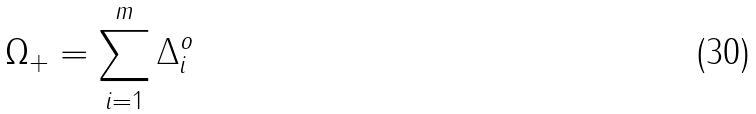<formula> <loc_0><loc_0><loc_500><loc_500>\Omega _ { + } = \sum _ { i = 1 } ^ { m } \Delta _ { i } ^ { o }</formula> 